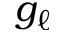<formula> <loc_0><loc_0><loc_500><loc_500>g _ { \ell }</formula> 